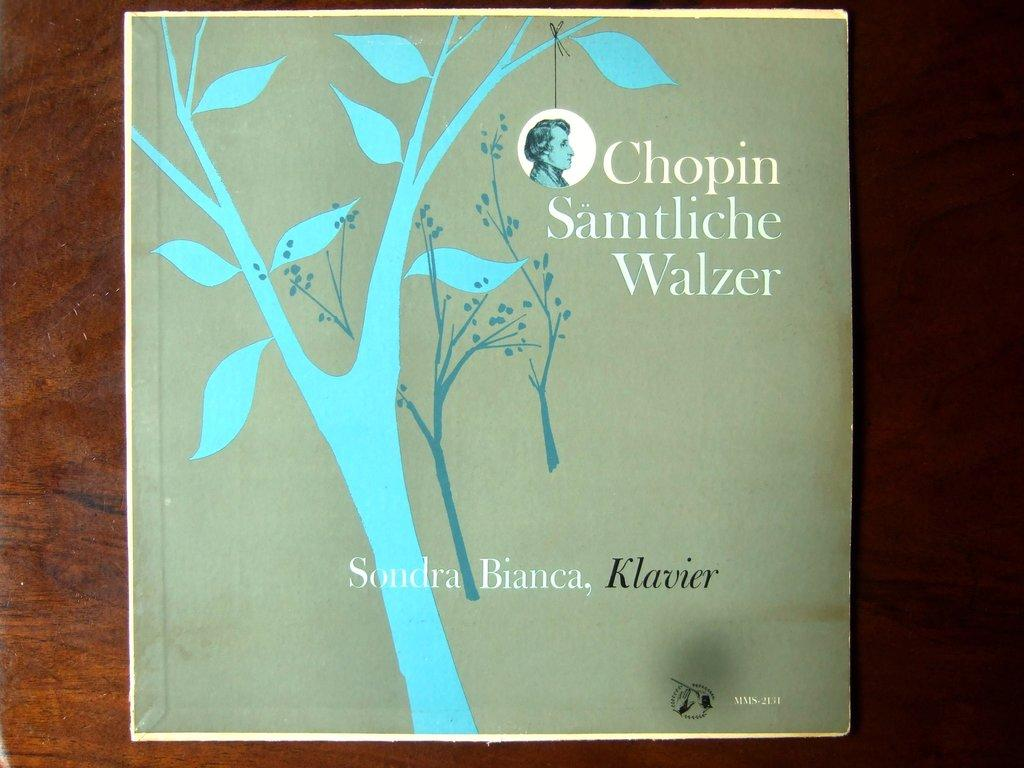<image>
Offer a succinct explanation of the picture presented. A Chopin album is illustrated with minimalist artwork of trees. 